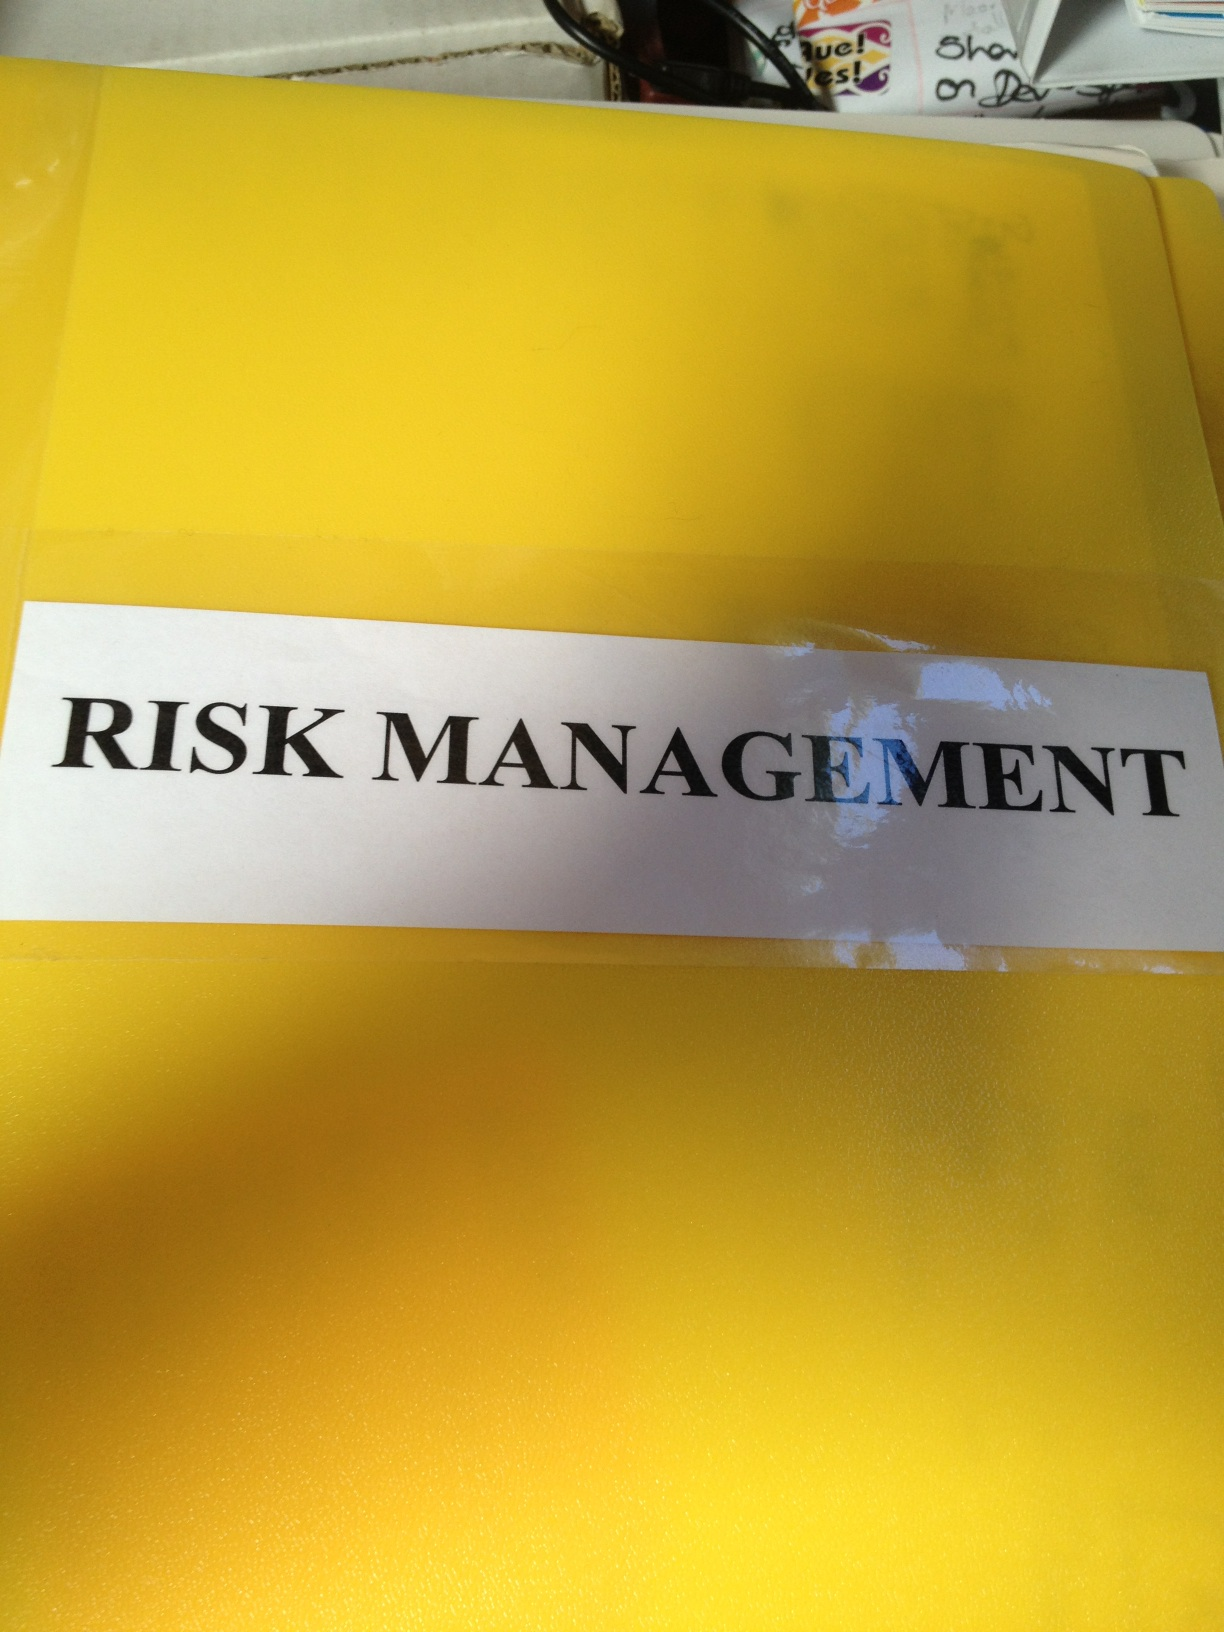Can you describe the contents of the photo? The photo shows a yellow folder with the label "RISK MANAGEMENT" clearly visible. The folder seems to be placed on a cluttered surface with other items partly visible in the background, such as a pair of glasses. How important is risk management in a business setting? Risk management is crucial in a business setting as it helps identify, evaluate, and prioritize potential risks that could negatively impact the organization. Effective risk management enables businesses to mitigate potential threats, ensuring smoother operations, protecting assets, and ultimately contributing to long-term success. Companies with robust risk management strategies can better navigate uncertainties and make informed decisions, which can lead to a competitive advantage in the market. What are some common risks that businesses face? Businesses commonly face a variety of risks, including financial risks (such as market fluctuations and credit risk), operational risks (including system failures and supply chain disruptions), strategic risks (like competition and changes in consumer preferences), and compliance risks (relating to laws and regulations). Additionally, businesses must also consider reputational risks, cybersecurity threats, and environmental risks as part of their overall risk management strategy. 